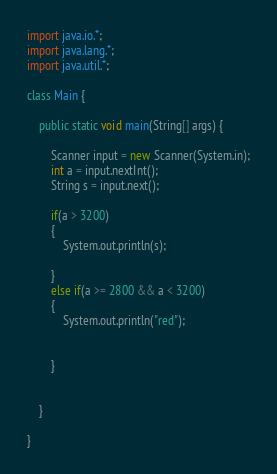<code> <loc_0><loc_0><loc_500><loc_500><_Java_>import java.io.*;
import java.lang.*;
import java.util.*;

class Main {
   
    public static void main(String[] args) {
        
        Scanner input = new Scanner(System.in);
        int a = input.nextInt();
        String s = input.next();
        
        if(a > 3200)
        {
            System.out.println(s);
           
        }
        else if(a >= 2800 && a < 3200)
        {
            System.out.println("red");
          
            
        }
        
        
    }
    
}
</code> 